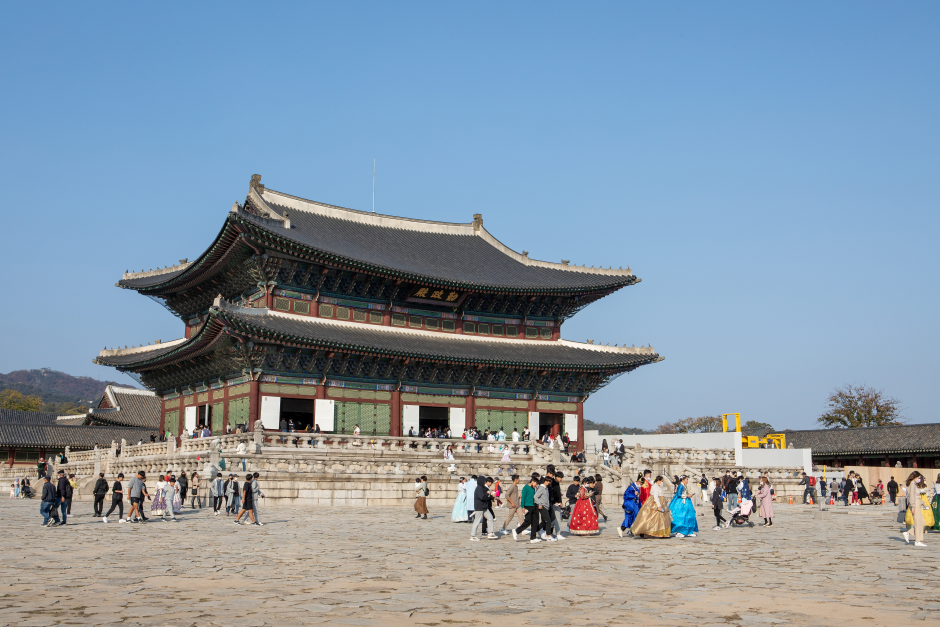What's happening in the scene? The image captures the historic and majestic Gyeongbokgung Palace, a cultural landmark in Seoul, South Korea. This iconic palace stands as a magnificent example of traditional Korean architecture, featuring a distinct green-tiled roof that contrasts beautifully with its red and white walls. The expansive courtyard in front of the palace is bustling with tourists, some of whom are dressed in traditional Korean hanbok, adding vibrancy and a sense of cultural immersion to the scene. The clear blue sky enhances the overall ambiance, making the palace appear even more splendid. This image not only showcases the architectural grandeur but also reflects the active engagement of people in experiencing and celebrating Korea's rich heritage. 